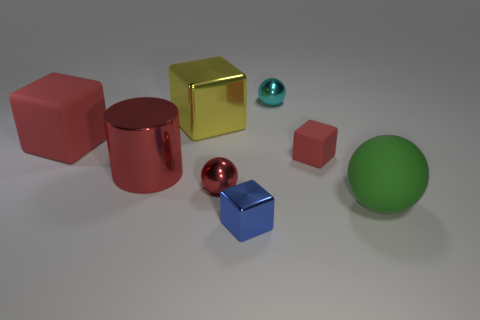There is a thing that is in front of the small red rubber cube and right of the cyan object; what is its size?
Provide a short and direct response. Large. Are there any big shiny cylinders right of the small cyan ball?
Give a very brief answer. No. Is there a metallic cube on the right side of the large yellow metallic thing that is on the right side of the metallic cylinder?
Offer a terse response. Yes. Are there an equal number of small red objects that are on the left side of the small red cube and red rubber blocks that are in front of the cyan metal thing?
Offer a terse response. No. There is a large cube that is made of the same material as the big ball; what color is it?
Your answer should be very brief. Red. Are there any other objects that have the same material as the big yellow thing?
Offer a very short reply. Yes. How many things are either tiny metallic cubes or tiny cyan spheres?
Provide a short and direct response. 2. Do the large ball and the tiny object that is in front of the big green thing have the same material?
Give a very brief answer. No. What is the size of the red matte block that is to the left of the large yellow metallic object?
Your answer should be very brief. Large. Is the number of red balls less than the number of tiny purple matte cubes?
Your response must be concise. No. 